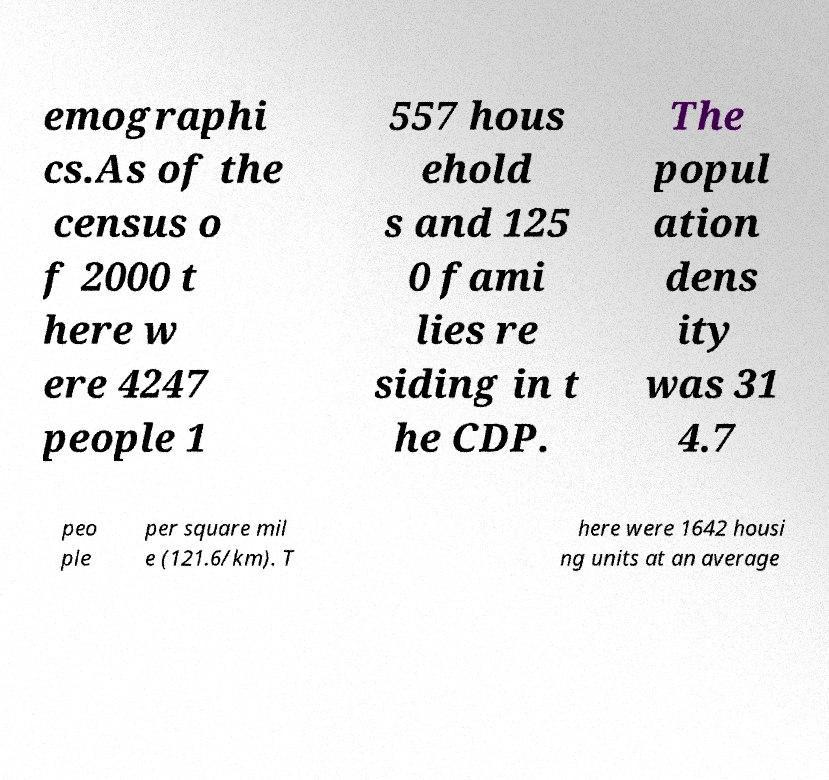Can you accurately transcribe the text from the provided image for me? emographi cs.As of the census o f 2000 t here w ere 4247 people 1 557 hous ehold s and 125 0 fami lies re siding in t he CDP. The popul ation dens ity was 31 4.7 peo ple per square mil e (121.6/km). T here were 1642 housi ng units at an average 